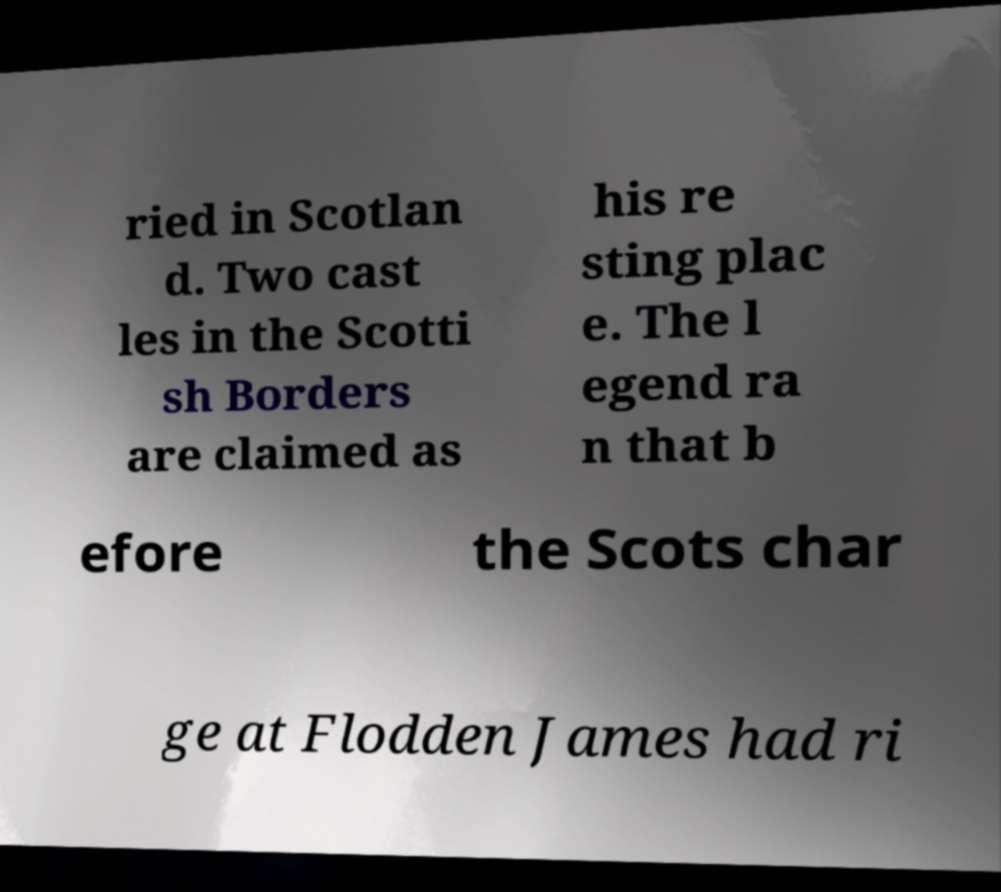I need the written content from this picture converted into text. Can you do that? ried in Scotlan d. Two cast les in the Scotti sh Borders are claimed as his re sting plac e. The l egend ra n that b efore the Scots char ge at Flodden James had ri 